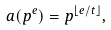<formula> <loc_0><loc_0><loc_500><loc_500>a ( p ^ { e } ) = p ^ { \lfloor e / t \rfloor } ,</formula> 